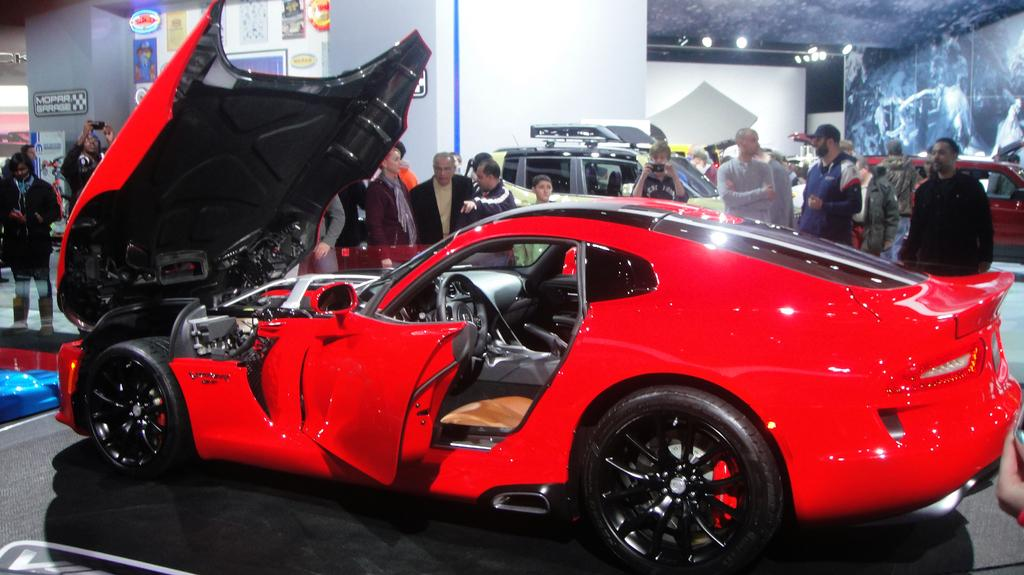What type of vehicles can be seen in the image? There are cars in the image. What are the people in the image doing? There are people standing in the image. What is the condition of the car with the opened bonnet? The car bonnet is opened in the image. What kind of signs or messages are present in the image? There are boards with text in the image. What type of lighting is visible in the image? There are lights on the ceiling in the image. What type of linen is draped over the boundary in the image? There is no linen or boundary present in the image. What scientific theory is being discussed by the people in the image? There is no indication of a scientific discussion or theory in the image. 